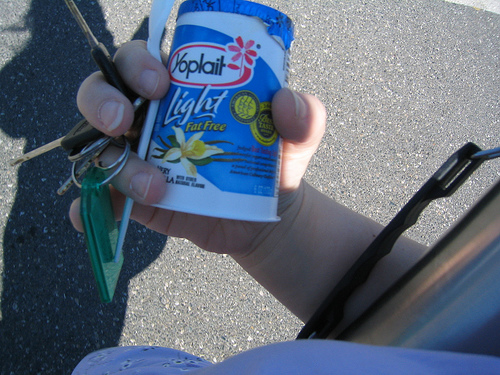<image>
Is there a blossom on the cup? Yes. Looking at the image, I can see the blossom is positioned on top of the cup, with the cup providing support. Is there a yogurt next to the ground? No. The yogurt is not positioned next to the ground. They are located in different areas of the scene. Is there a yogurt above the ground? Yes. The yogurt is positioned above the ground in the vertical space, higher up in the scene. 